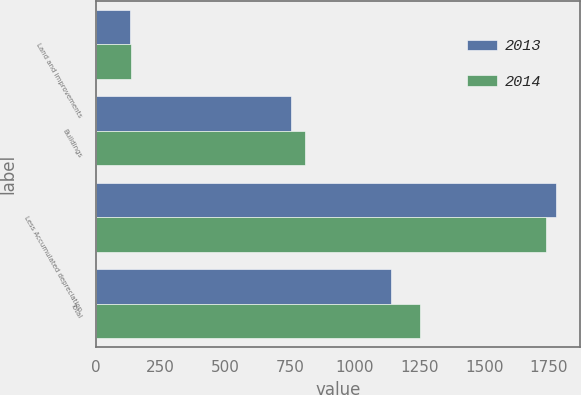Convert chart. <chart><loc_0><loc_0><loc_500><loc_500><stacked_bar_chart><ecel><fcel>Land and improvements<fcel>Buildings<fcel>Less Accumulated depreciation<fcel>Total<nl><fcel>2013<fcel>130<fcel>754<fcel>1780<fcel>1139<nl><fcel>2014<fcel>135<fcel>809<fcel>1738<fcel>1252<nl></chart> 